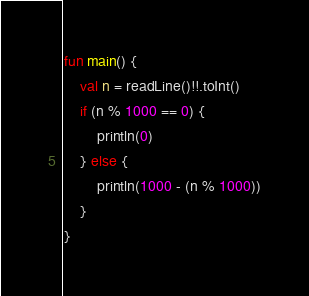<code> <loc_0><loc_0><loc_500><loc_500><_Kotlin_>fun main() {
    val n = readLine()!!.toInt()
    if (n % 1000 == 0) {
        println(0)
    } else {
        println(1000 - (n % 1000))
    }
}</code> 